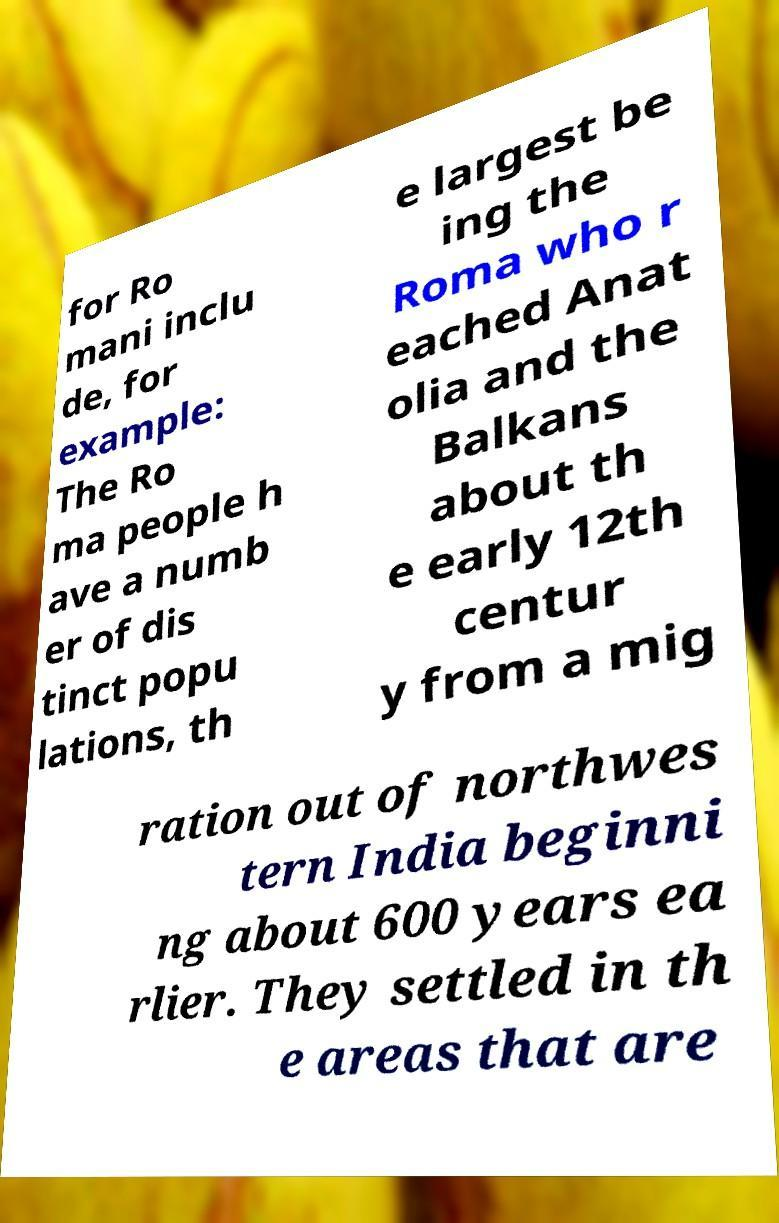There's text embedded in this image that I need extracted. Can you transcribe it verbatim? for Ro mani inclu de, for example: The Ro ma people h ave a numb er of dis tinct popu lations, th e largest be ing the Roma who r eached Anat olia and the Balkans about th e early 12th centur y from a mig ration out of northwes tern India beginni ng about 600 years ea rlier. They settled in th e areas that are 